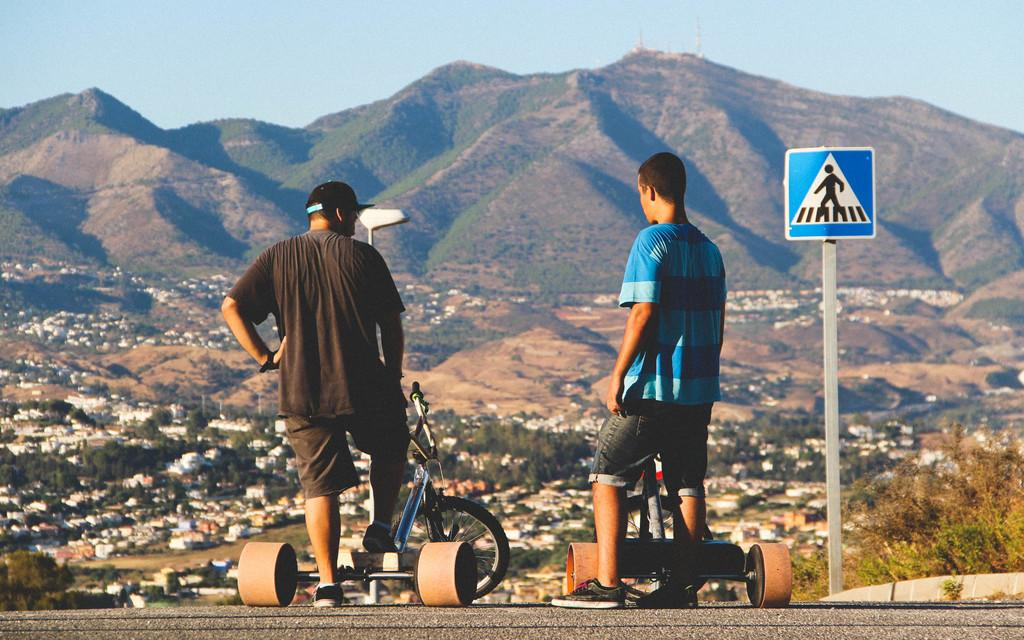How many people are present in the image? There are two persons in the image. What can be seen on the road in the image? There are two vehicles on the road in the image. What is the tall, vertical object in the image? There is a pole in the image. What is visible in the background of the image? Buildings, trees, and mountains are visible in the background of the image. What part of the natural environment is visible in the image? The sky is visible in the image. What type of plot is being used to grow the light on the sheet in the image? There is no plot, light, or sheet present in the image. 